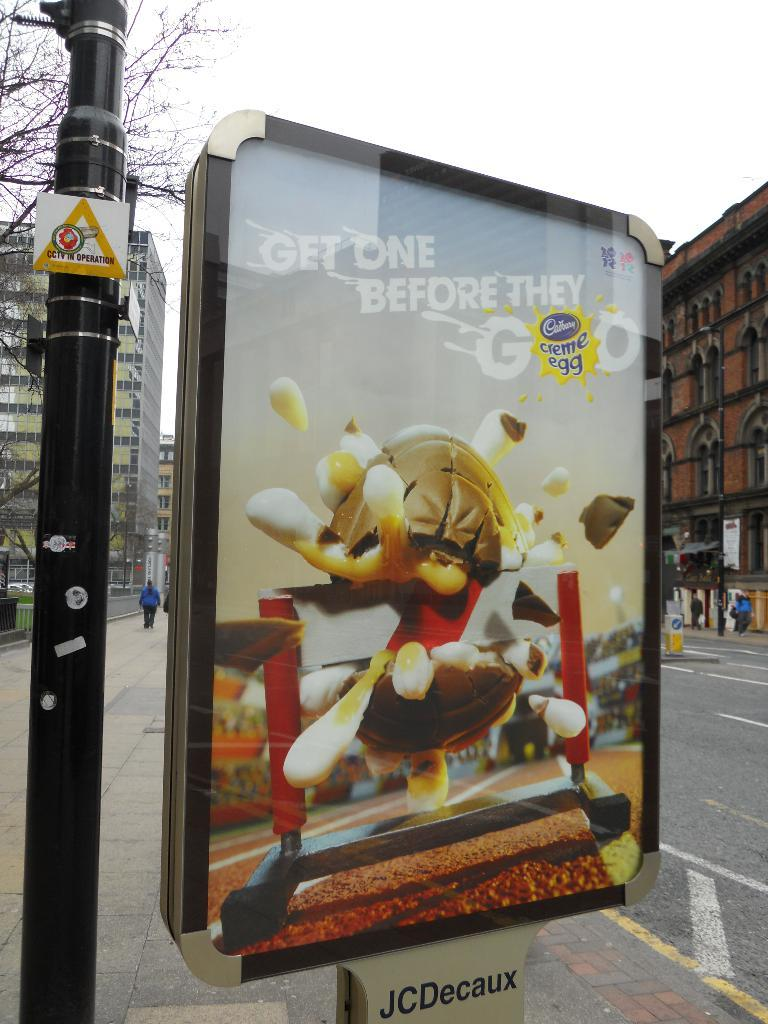<image>
Render a clear and concise summary of the photo. A large, enclosed poster on the side of the street is advertising Cadbury eggs. 